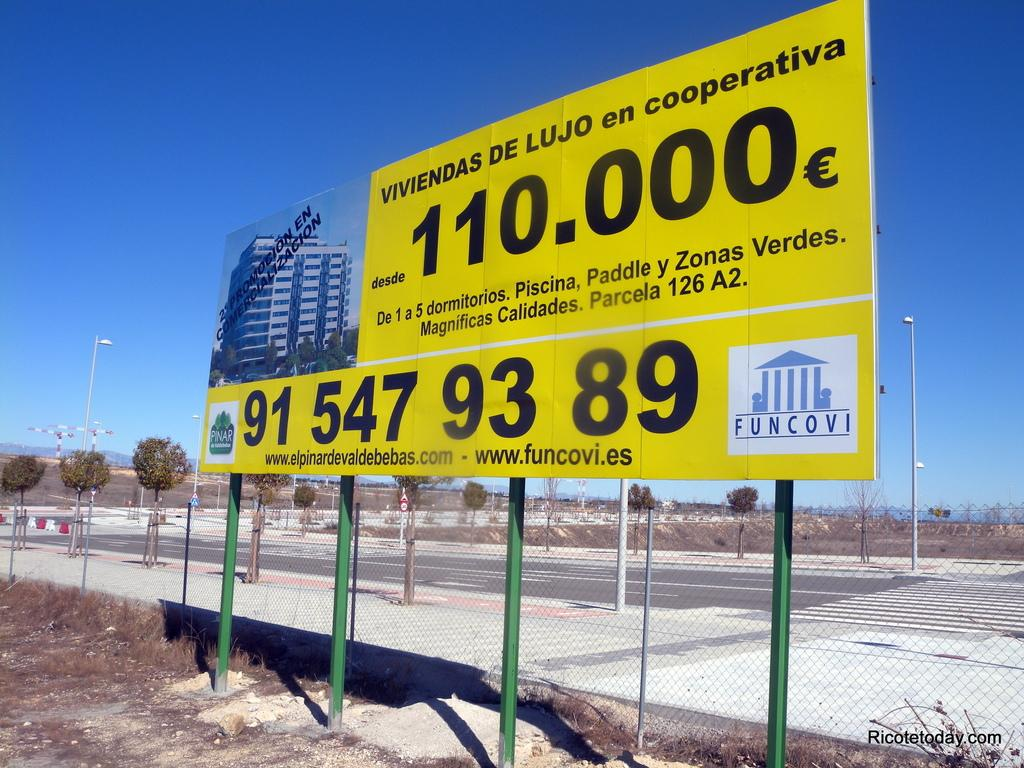<image>
Render a clear and concise summary of the photo. A large yellow sign with a building on it that says viviendes de lujo en cooperativa. 